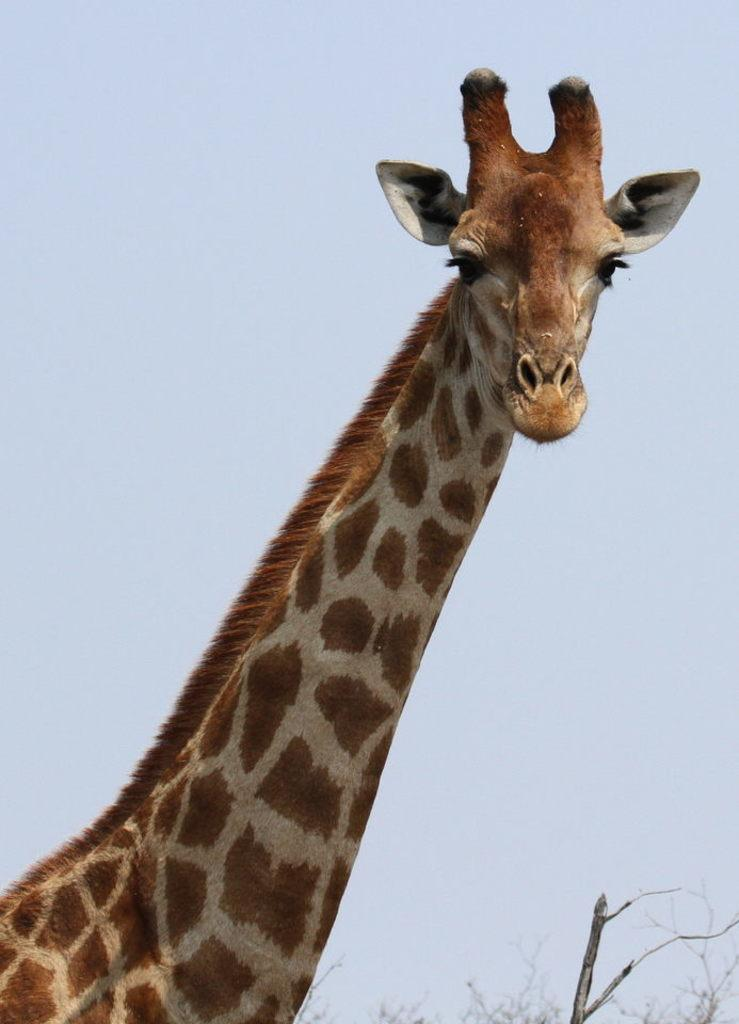What animal can be seen in the image? There is a giraffe in the image. What type of vegetation is present in the image? There are trees in the image. What part of the natural environment is visible in the image? The sky is visible in the image. What type of truck can be seen in the image? There is no truck present in the image; it features a giraffe and trees. How does the giraffe provide comfort to the trees in the image? The giraffe does not provide comfort to the trees in the image; it is an animal and not capable of providing comfort in this context. 